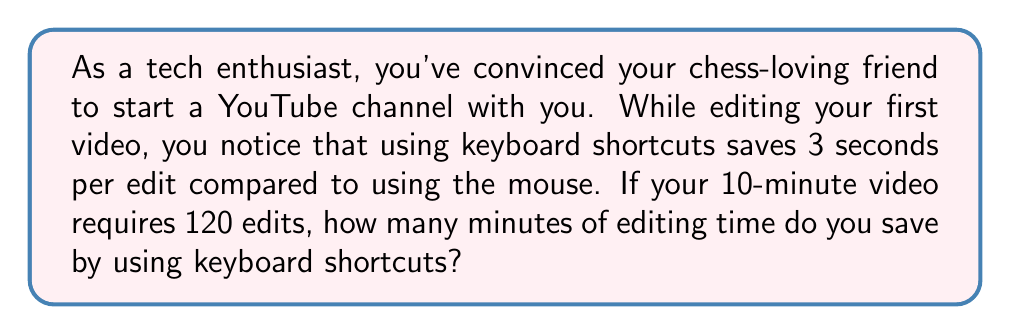Solve this math problem. Let's break this problem down step-by-step:

1. Calculate the total time saved per edit:
   $$ \text{Time saved per edit} = 3 \text{ seconds} $$

2. Determine the total number of edits:
   $$ \text{Total edits} = 120 $$

3. Calculate the total time saved in seconds:
   $$ \text{Total time saved (seconds)} = \text{Time saved per edit} \times \text{Total edits} $$
   $$ \text{Total time saved (seconds)} = 3 \times 120 = 360 \text{ seconds} $$

4. Convert the time saved from seconds to minutes:
   $$ \text{Total time saved (minutes)} = \frac{\text{Total time saved (seconds)}}{60 \text{ seconds/minute}} $$
   $$ \text{Total time saved (minutes)} = \frac{360}{60} = 6 \text{ minutes} $$

Therefore, by using keyboard shortcuts, you save 6 minutes of editing time for your 10-minute video.
Answer: 6 minutes 